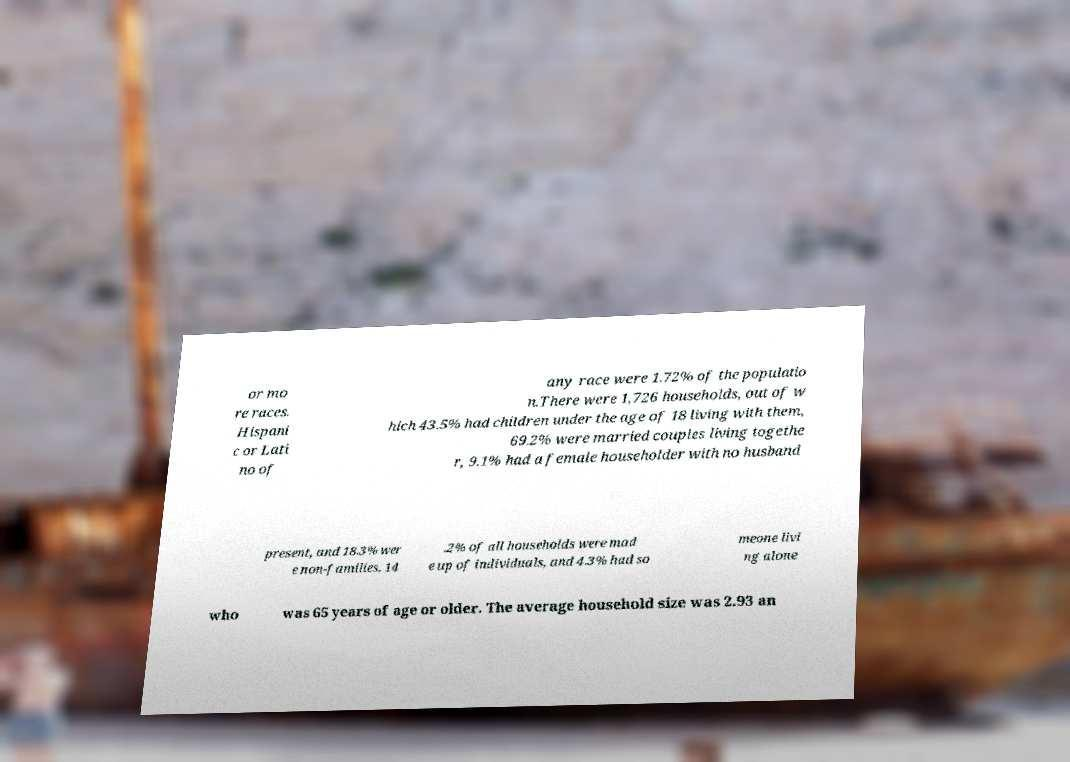What messages or text are displayed in this image? I need them in a readable, typed format. or mo re races. Hispani c or Lati no of any race were 1.72% of the populatio n.There were 1,726 households, out of w hich 43.5% had children under the age of 18 living with them, 69.2% were married couples living togethe r, 9.1% had a female householder with no husband present, and 18.3% wer e non-families. 14 .2% of all households were mad e up of individuals, and 4.3% had so meone livi ng alone who was 65 years of age or older. The average household size was 2.93 an 